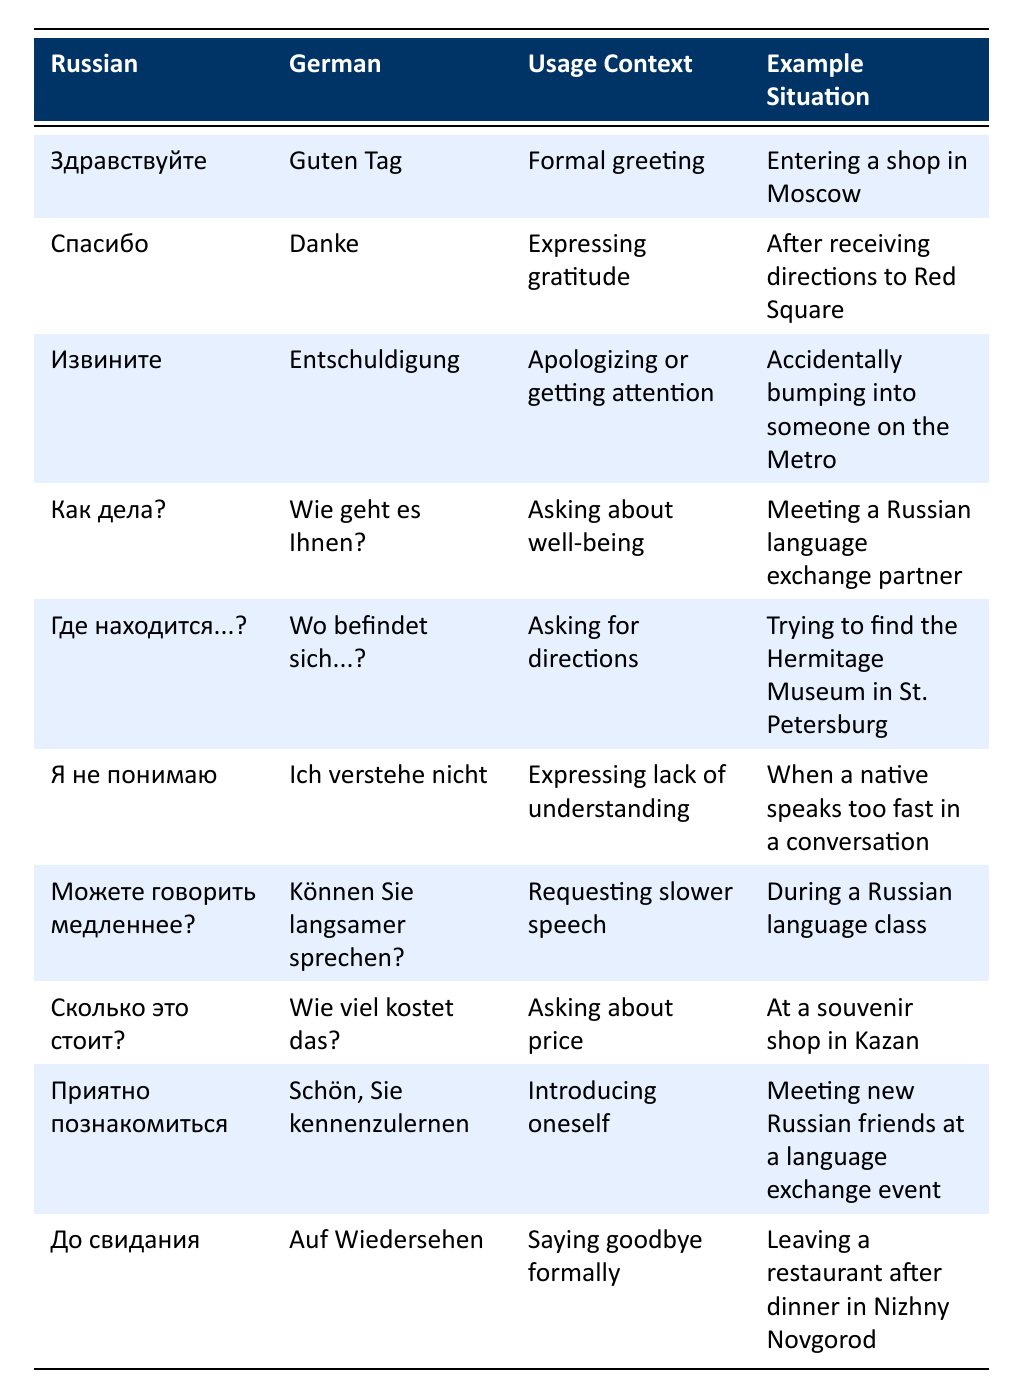What is the German translation for the Russian phrase "Спасибо"? The table lists the phrase "Спасибо" in the Russian column, and its German translation is given in the corresponding row as "Danke."
Answer: Danke What usage context is provided for the phrase "Извините"? The table shows that "Извините" is used for "Apologizing or getting attention" according to the usage context column.
Answer: Apologizing or getting attention Which phrase would you use to ask someone about their well-being? To ask about well-being, you would use the phrase "Как дела?" which is provided in the table.
Answer: Как дела? How many phrases in the table are related to asking questions? The table contains three phrases related to asking questions: "Где находится...?", "Как дела?", and "Сколько это стоит?"
Answer: Three Is "До свидания" used for saying goodbye formally? The table indicates that "До свидания" has the usage context of saying goodbye formally, confirming that it is true.
Answer: Yes Which Russian phrase corresponds to the German "Schön, Sie kennenzulernen"? By looking at the table, the German phrase "Schön, Sie kennenzulernen" corresponds to the Russian phrase "Приятно познакомиться."
Answer: Приятно познакомиться What is the example situation for the phrase "Я не понимаю"? The example situation for "Я не понимаю" is given as "When a native speaks too fast in a conversation."
Answer: When a native speaks too fast in a conversation Which phrase would you use in a shop to ask about a price? The phrase to use in a shop to inquire about a price is "Сколько это стоит?", as indicated in the table.
Answer: Сколько это стоит? How do the phrases "Здравствуйте" and "До свидания" differ in terms of usage context? "Здравствуйте" is for a formal greeting while "До свидания" is for saying goodbye formally. This highlights their respective contexts as greetings and farewells.
Answer: Formal greeting and saying goodbye formally If you wanted to express gratitude after receiving help, which phrase could you use? To express gratitude after receiving help, you could use "Спасибо," which translates to "Danke" in German according to the table.
Answer: Спасибо 